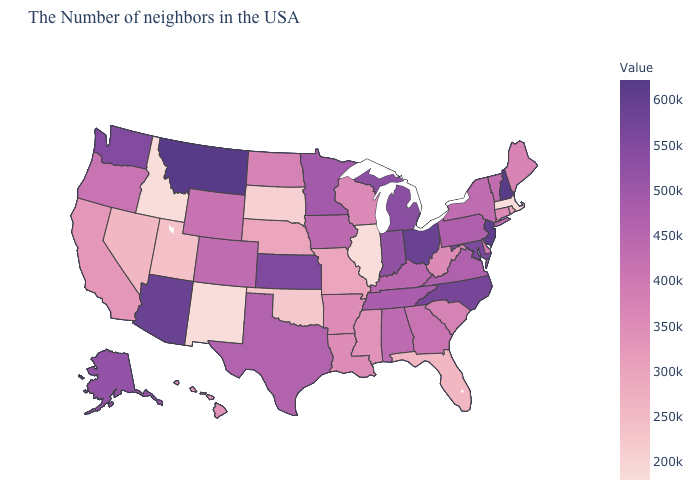Does Montana have the highest value in the USA?
Quick response, please. Yes. Which states have the lowest value in the USA?
Write a very short answer. Massachusetts, Illinois, New Mexico, Idaho. Does Montana have the highest value in the USA?
Write a very short answer. Yes. Does Vermont have the highest value in the Northeast?
Give a very brief answer. No. Which states have the lowest value in the West?
Keep it brief. New Mexico, Idaho. Which states have the highest value in the USA?
Keep it brief. Montana. Does Kentucky have the highest value in the South?
Give a very brief answer. No. 